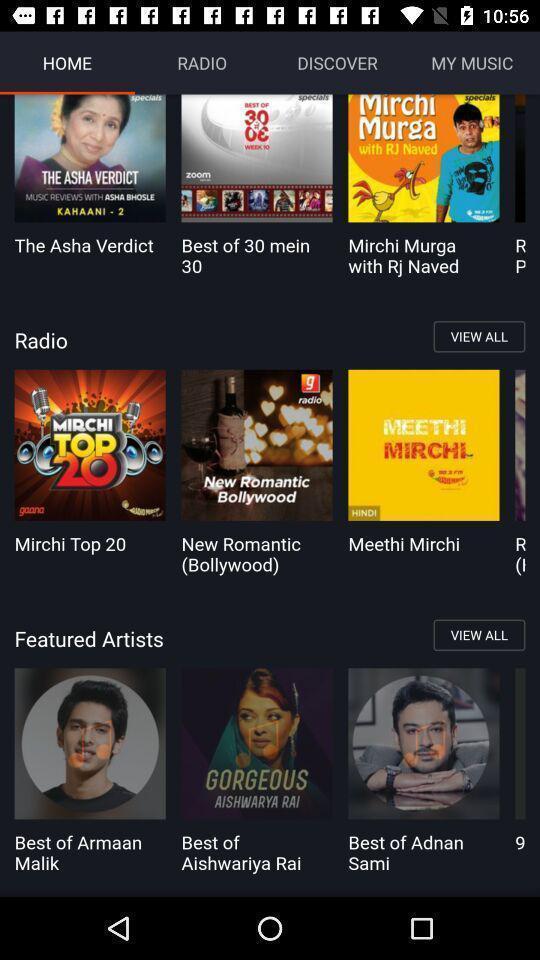Describe the visual elements of this screenshot. List of music albums available in the app. 